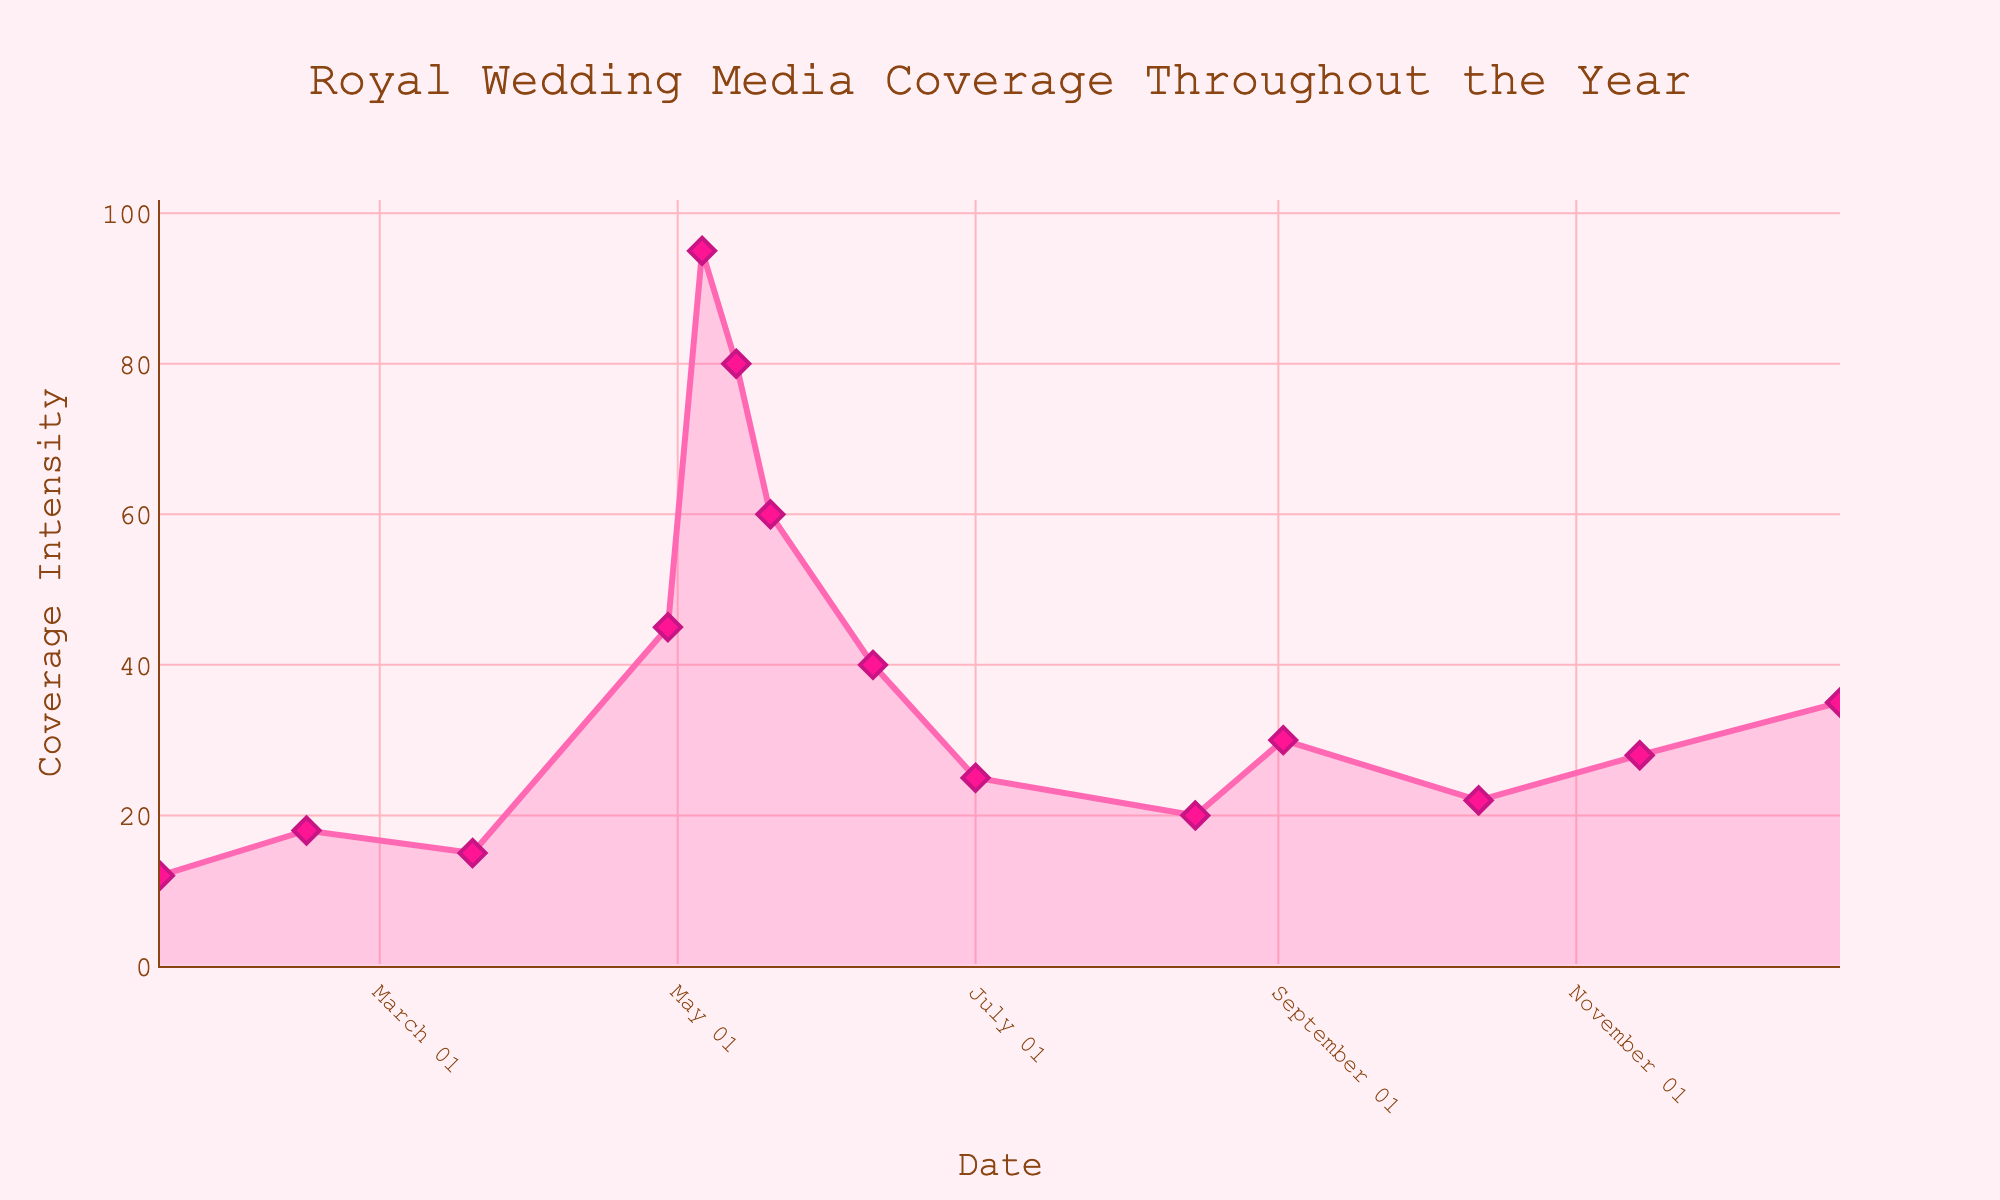What's the title of the density plot? The title of the plot is usually placed at the top in a larger font size. In this case, it reads "Royal Wedding Media Coverage Throughout the Year".
Answer: Royal Wedding Media Coverage Throughout the Year What are the axes labeled as? The x-axis title is typically at the bottom of the axis, and the y-axis title is along the side. Here, the x-axis is labeled "Date" and the y-axis is labeled "Coverage Intensity".
Answer: Date; Coverage Intensity On which date is the media coverage intensity the highest? By inspecting the peaks in the line plot, the highest point is cleary on May 6th with the Coverage Intensity being 95.
Answer: May 6 What is the media coverage intensity on April 29? Locate the data point on the plot corresponding to April 29. The y-value there represents the Coverage Intensity which is 45.
Answer: 45 During which month does the plot show the most significant increase in media coverage intensity? Observe the steepest upward slope in the plot. From late April to early May, there is a rapid increase in the line, indicating that May has the most significant rise.
Answer: May What is the general trend of media coverage intensity from January to July? By following the plot from left to right, the line moves gradually upwards peaking in May with some decreases afterward, suggesting an overall increasing trend until July.
Answer: Increasing until July Which two consecutive dates have the largest drop in media coverage intensity? Identify the largest downward slope between two adjacent points. The steepest drop is between May 13 (80) and May 20 (60), a decrease of 20.
Answer: May 13 and May 20 How many data points are there in total? Count the number of markers shown on the plot, one for each date, which corresponds to 14 points.
Answer: 14 What's the average media coverage intensity for the month of May? Sum the intensities for all May dates (April 29 counts as part of buildup): (45 + 95 + 80 + 60) = 280, then divide by the number of days (4): 280/4 = 70.
Answer: 70 During which month is the media coverage intensity the lowest, and what is that value? The lowest point in each month appears in August, with a coverage intensity of 20.
Answer: August; 20 